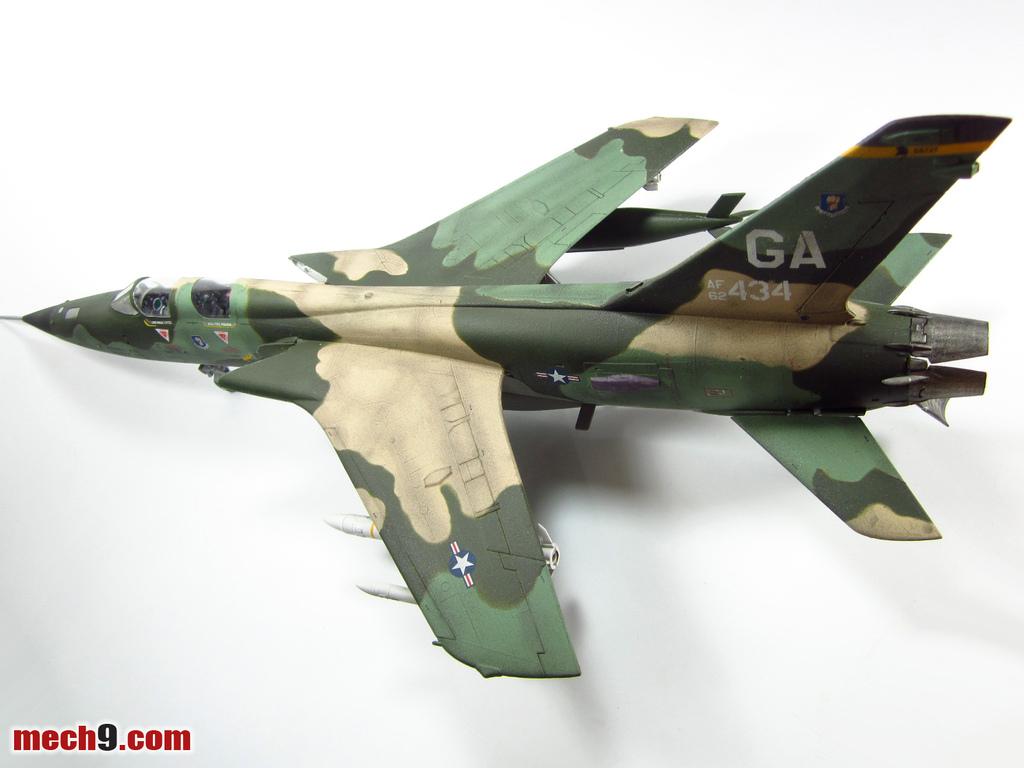What is the id number of the plane?
Offer a terse response. 434. What color is the plane?
Offer a very short reply. Answering does not require reading text in the image. 